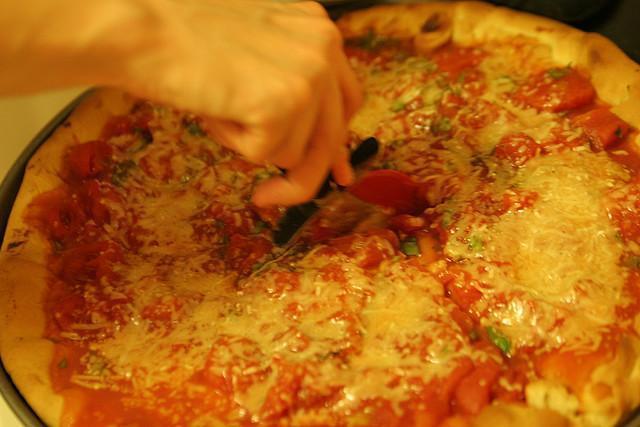How many people are in this photo?
Give a very brief answer. 1. 